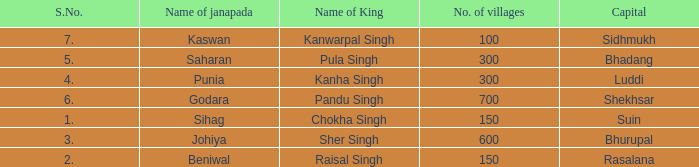What is the highest S number with a capital of Shekhsar? 6.0. 